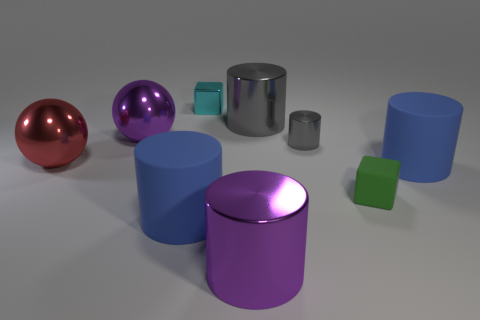There is another cylinder that is the same color as the small metal cylinder; what is its material?
Keep it short and to the point. Metal. What number of objects are either large purple things or gray cylinders?
Offer a very short reply. 4. Is the material of the small block that is left of the large gray cylinder the same as the tiny green thing?
Provide a short and direct response. No. The purple sphere has what size?
Your response must be concise. Large. There is a metallic object that is the same color as the small cylinder; what is its shape?
Offer a very short reply. Cylinder. What number of cubes are either purple things or large gray objects?
Your answer should be very brief. 0. Is the number of large metal objects that are right of the small green cube the same as the number of big blue things left of the big purple cylinder?
Offer a terse response. No. What is the size of the other object that is the same shape as the small green rubber object?
Keep it short and to the point. Small. There is a object that is to the left of the small cyan shiny thing and in front of the large red thing; what is its size?
Provide a short and direct response. Large. There is a tiny cylinder; are there any tiny green objects behind it?
Your answer should be very brief. No. 